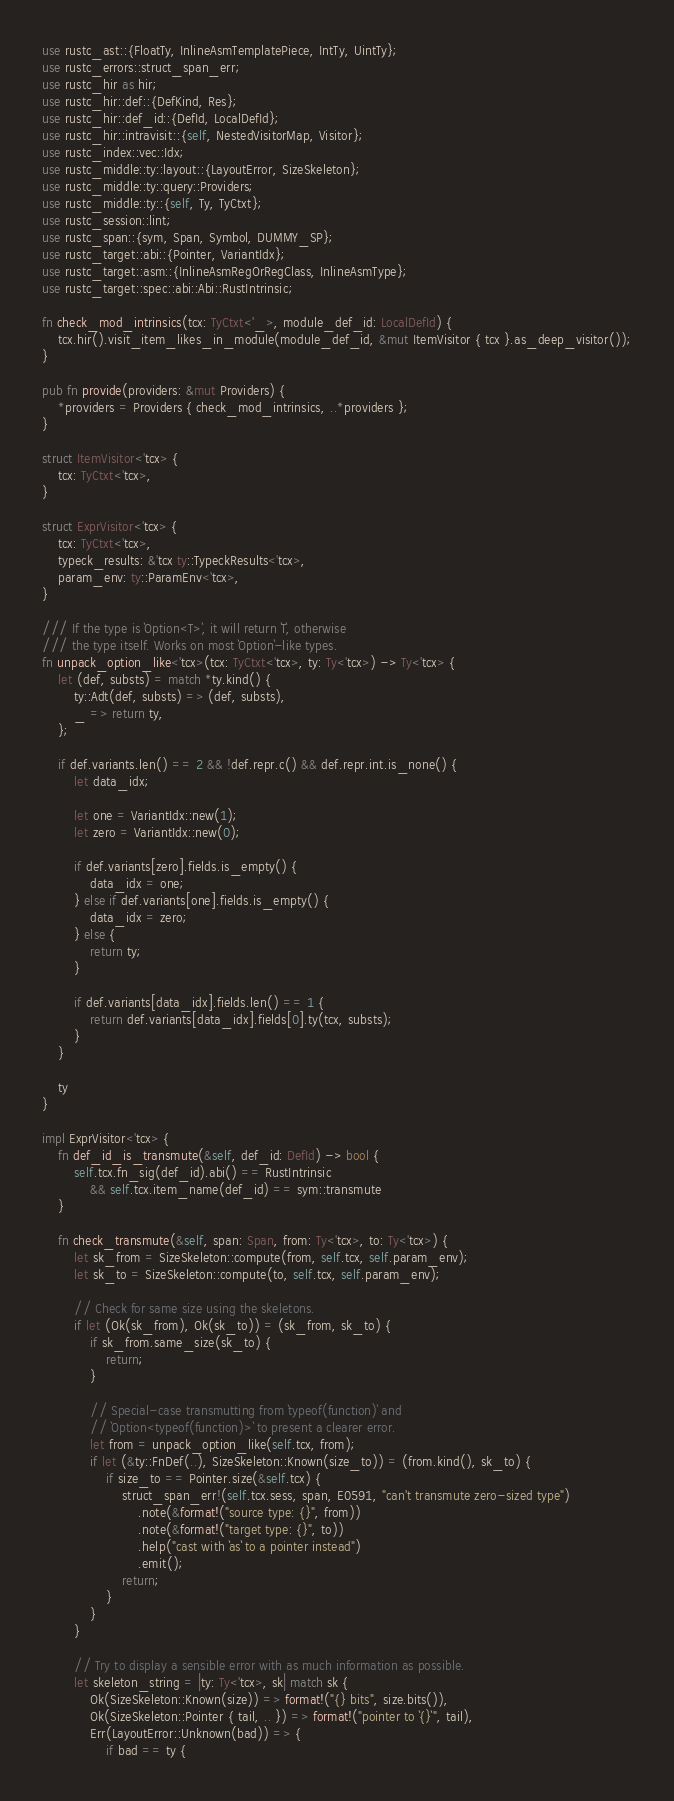<code> <loc_0><loc_0><loc_500><loc_500><_Rust_>use rustc_ast::{FloatTy, InlineAsmTemplatePiece, IntTy, UintTy};
use rustc_errors::struct_span_err;
use rustc_hir as hir;
use rustc_hir::def::{DefKind, Res};
use rustc_hir::def_id::{DefId, LocalDefId};
use rustc_hir::intravisit::{self, NestedVisitorMap, Visitor};
use rustc_index::vec::Idx;
use rustc_middle::ty::layout::{LayoutError, SizeSkeleton};
use rustc_middle::ty::query::Providers;
use rustc_middle::ty::{self, Ty, TyCtxt};
use rustc_session::lint;
use rustc_span::{sym, Span, Symbol, DUMMY_SP};
use rustc_target::abi::{Pointer, VariantIdx};
use rustc_target::asm::{InlineAsmRegOrRegClass, InlineAsmType};
use rustc_target::spec::abi::Abi::RustIntrinsic;

fn check_mod_intrinsics(tcx: TyCtxt<'_>, module_def_id: LocalDefId) {
    tcx.hir().visit_item_likes_in_module(module_def_id, &mut ItemVisitor { tcx }.as_deep_visitor());
}

pub fn provide(providers: &mut Providers) {
    *providers = Providers { check_mod_intrinsics, ..*providers };
}

struct ItemVisitor<'tcx> {
    tcx: TyCtxt<'tcx>,
}

struct ExprVisitor<'tcx> {
    tcx: TyCtxt<'tcx>,
    typeck_results: &'tcx ty::TypeckResults<'tcx>,
    param_env: ty::ParamEnv<'tcx>,
}

/// If the type is `Option<T>`, it will return `T`, otherwise
/// the type itself. Works on most `Option`-like types.
fn unpack_option_like<'tcx>(tcx: TyCtxt<'tcx>, ty: Ty<'tcx>) -> Ty<'tcx> {
    let (def, substs) = match *ty.kind() {
        ty::Adt(def, substs) => (def, substs),
        _ => return ty,
    };

    if def.variants.len() == 2 && !def.repr.c() && def.repr.int.is_none() {
        let data_idx;

        let one = VariantIdx::new(1);
        let zero = VariantIdx::new(0);

        if def.variants[zero].fields.is_empty() {
            data_idx = one;
        } else if def.variants[one].fields.is_empty() {
            data_idx = zero;
        } else {
            return ty;
        }

        if def.variants[data_idx].fields.len() == 1 {
            return def.variants[data_idx].fields[0].ty(tcx, substs);
        }
    }

    ty
}

impl ExprVisitor<'tcx> {
    fn def_id_is_transmute(&self, def_id: DefId) -> bool {
        self.tcx.fn_sig(def_id).abi() == RustIntrinsic
            && self.tcx.item_name(def_id) == sym::transmute
    }

    fn check_transmute(&self, span: Span, from: Ty<'tcx>, to: Ty<'tcx>) {
        let sk_from = SizeSkeleton::compute(from, self.tcx, self.param_env);
        let sk_to = SizeSkeleton::compute(to, self.tcx, self.param_env);

        // Check for same size using the skeletons.
        if let (Ok(sk_from), Ok(sk_to)) = (sk_from, sk_to) {
            if sk_from.same_size(sk_to) {
                return;
            }

            // Special-case transmutting from `typeof(function)` and
            // `Option<typeof(function)>` to present a clearer error.
            let from = unpack_option_like(self.tcx, from);
            if let (&ty::FnDef(..), SizeSkeleton::Known(size_to)) = (from.kind(), sk_to) {
                if size_to == Pointer.size(&self.tcx) {
                    struct_span_err!(self.tcx.sess, span, E0591, "can't transmute zero-sized type")
                        .note(&format!("source type: {}", from))
                        .note(&format!("target type: {}", to))
                        .help("cast with `as` to a pointer instead")
                        .emit();
                    return;
                }
            }
        }

        // Try to display a sensible error with as much information as possible.
        let skeleton_string = |ty: Ty<'tcx>, sk| match sk {
            Ok(SizeSkeleton::Known(size)) => format!("{} bits", size.bits()),
            Ok(SizeSkeleton::Pointer { tail, .. }) => format!("pointer to `{}`", tail),
            Err(LayoutError::Unknown(bad)) => {
                if bad == ty {</code> 